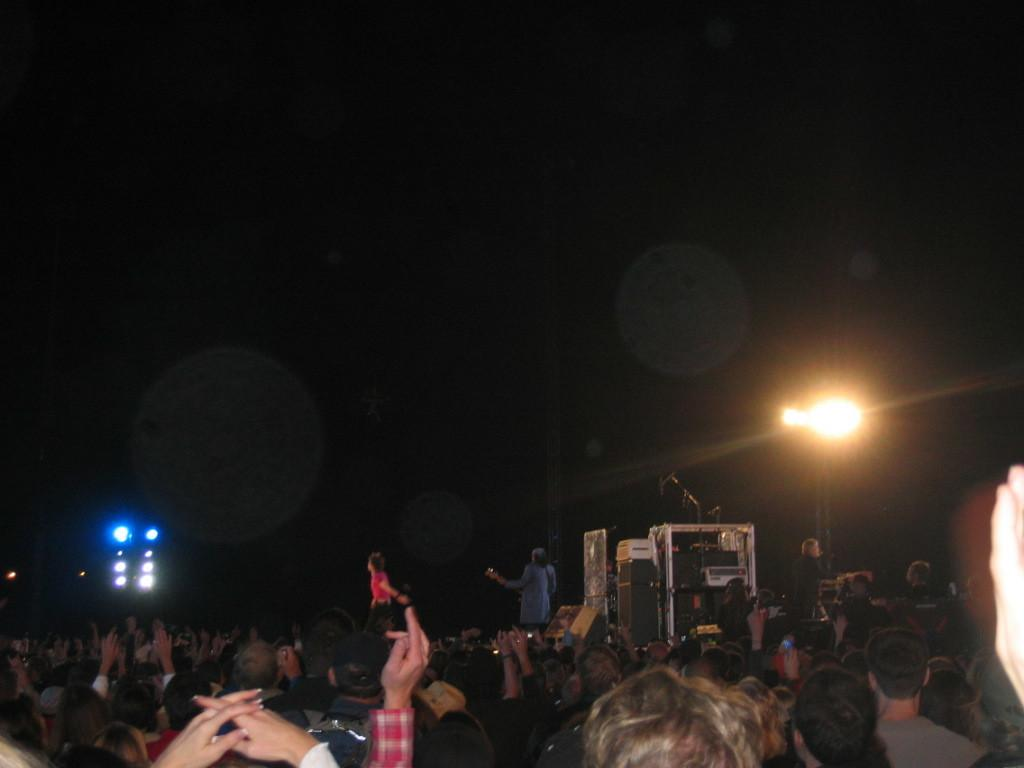How many people are present in the image? There are many people in the image. What color are the lights on the left side of the image? There are blue color lights on the left side of the image. What can be seen on the right side of the image? There is a big light on the right side of the image. What is the condition of the sky in the image? The sky is dark in the image. What type of nose can be seen on the orange tree in the image? There is no orange tree or nose present in the image. What type of wood is used to make the chairs in the image? There is no information about the chairs or the wood used to make them in the image. 